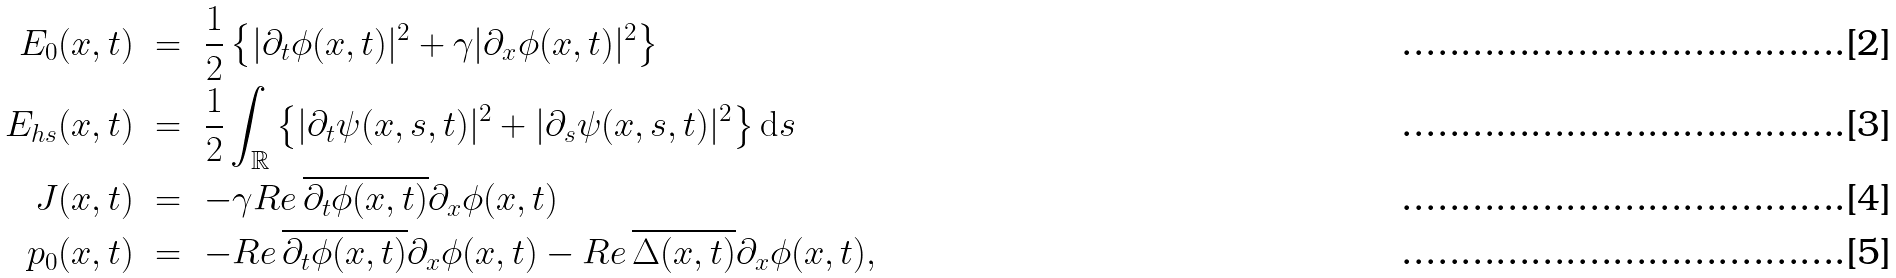<formula> <loc_0><loc_0><loc_500><loc_500>E _ { 0 } ( x , t ) \ & = \ \frac { 1 } { 2 } \left \{ | \partial _ { t } \phi ( x , t ) | ^ { 2 } + \gamma | \partial _ { x } \phi ( x , t ) | ^ { 2 } \right \} \\ E _ { h s } ( x , t ) \ & = \ \frac { 1 } { 2 } \int _ { \mathbb { R } } \left \{ | \partial _ { t } \psi ( x , s , t ) | ^ { 2 } + | \partial _ { s } \psi ( x , s , t ) | ^ { 2 } \right \} \mathrm d s \\ J ( x , t ) \ & = \ - \gamma R e \, \overline { \partial _ { t } \phi ( x , t ) } \partial _ { x } \phi ( x , t ) \\ p _ { 0 } ( x , t ) \ & = \ - R e \, \overline { \partial _ { t } \phi ( x , t ) } \partial _ { x } \phi ( x , t ) - R e \, \overline { \Delta ( x , t ) } \partial _ { x } \phi ( x , t ) ,</formula> 